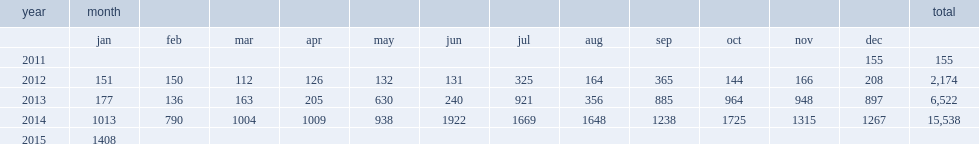How many iraqis were killed in april 2012? 126.0. How many iraqis were killed in may 2012? 132.0. 